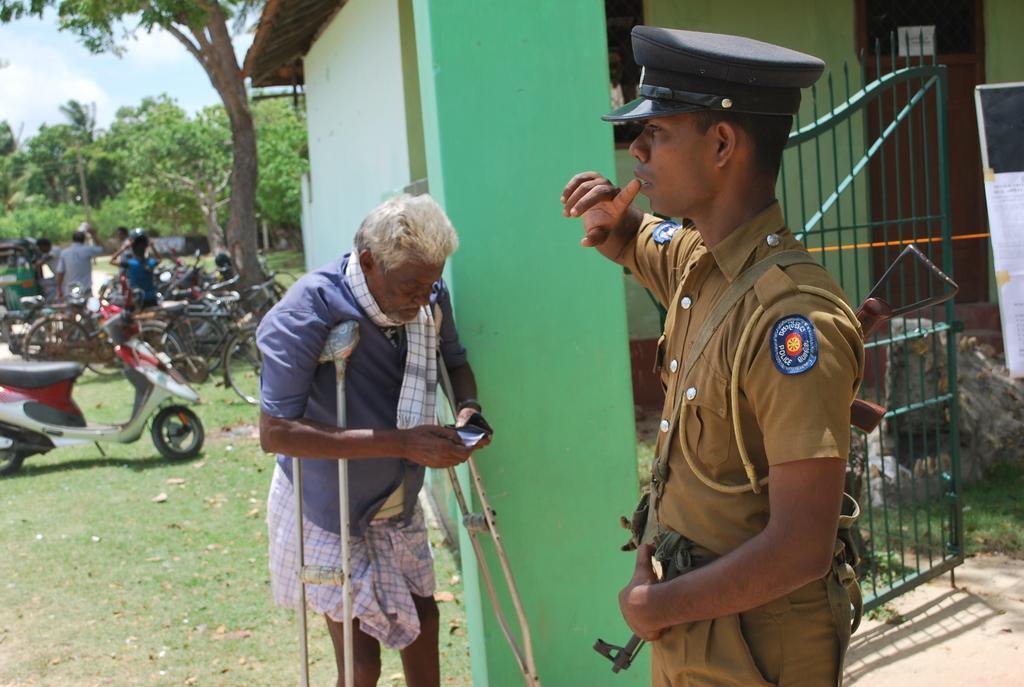Could you give a brief overview of what you see in this image? In this image we can see trees, grass. And we can see a few people near the vehicles. And we can see one old man. And we can see one person in uniform near the gate. And we can see the door and the wall. 